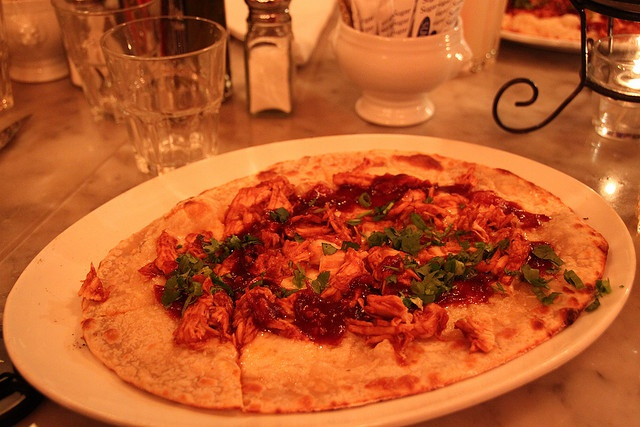Describe the objects in this image and their specific colors. I can see dining table in red, brown, orange, and maroon tones, pizza in brown, red, and maroon tones, cup in brown, maroon, and red tones, bowl in brown, red, orange, and salmon tones, and cup in brown, maroon, and red tones in this image. 